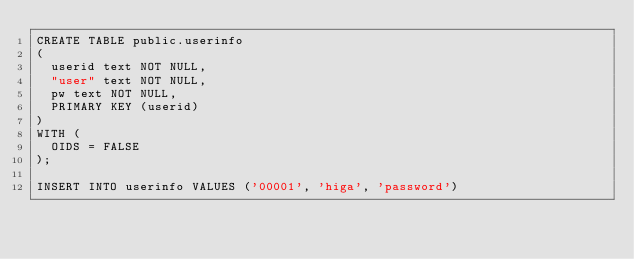<code> <loc_0><loc_0><loc_500><loc_500><_SQL_>CREATE TABLE public.userinfo 
(
  userid text NOT NULL,
  "user" text NOT NULL,
  pw text NOT NULL,
  PRIMARY KEY (userid)
)
WITH (
  OIDS = FALSE
);

INSERT INTO userinfo VALUES ('00001', 'higa', 'password')
</code> 